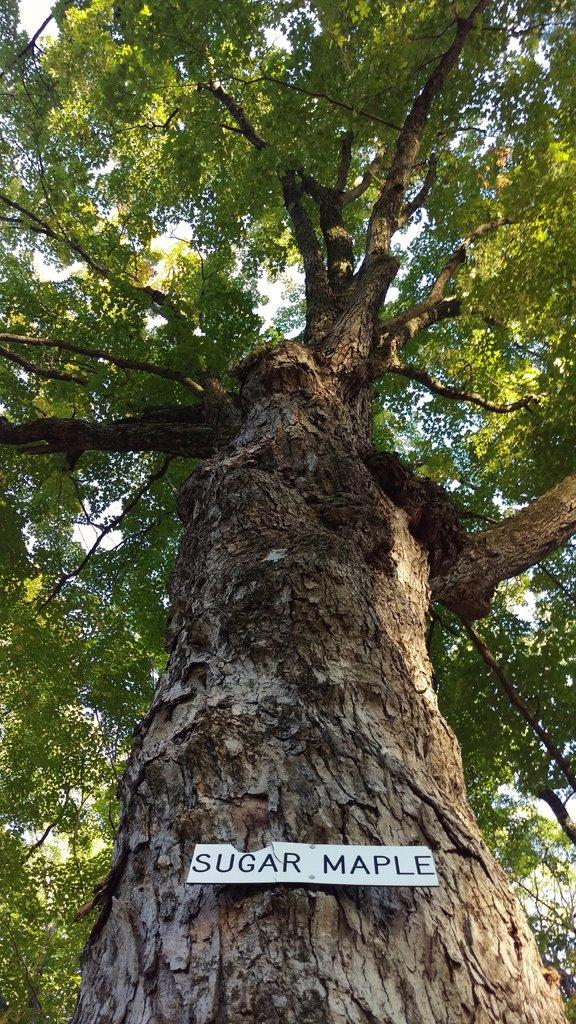What is the main object in the image? There is a tree in the image. What is attached to the tree? There is a board pasted on the tree. What can be found on the board? There is text on the board. What can be seen in the background of the image? The sky is visible in the background of the image. What type of pets can be seen playing in the sleet in the image? There is no mention of pets or sleet in the image; it features a tree with a board and text, and a visible sky in the background. 